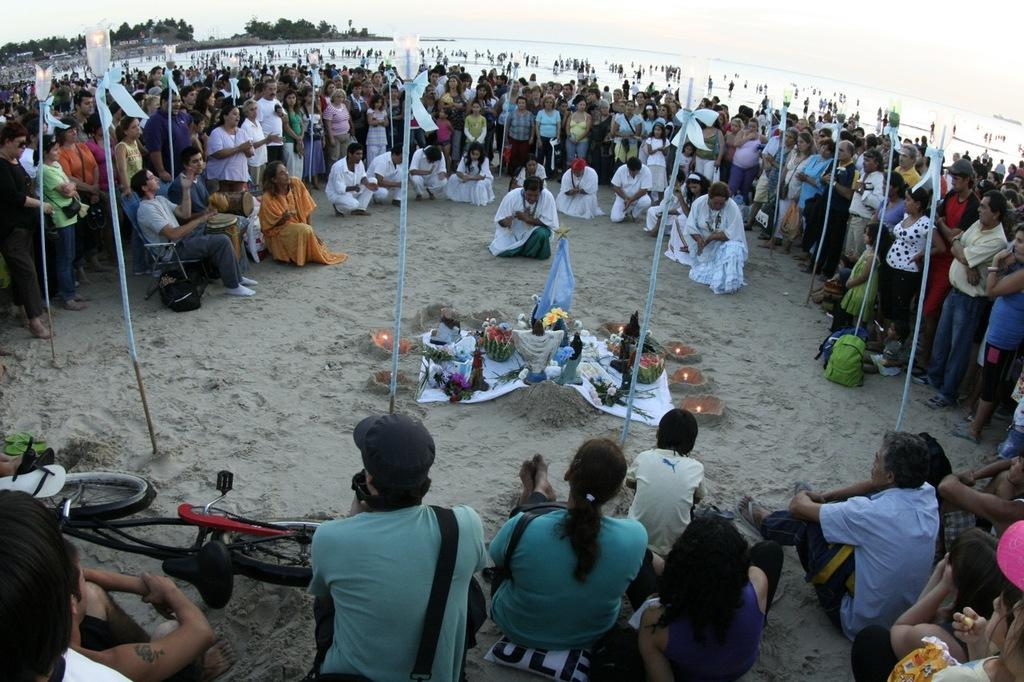Who or what is present in the image? There are people in the image. What can be seen besides the people? There is a bicycle, footwear, light poles, objects on the sand, water, people, trees, and the sky visible in the image. What type of flag is being waved by the people in the image? There is no flag visible in the image; people are not waving any flags. How do the people in the image feel about the situation? The image does not provide any information about the feelings or emotions of the people in the image. 